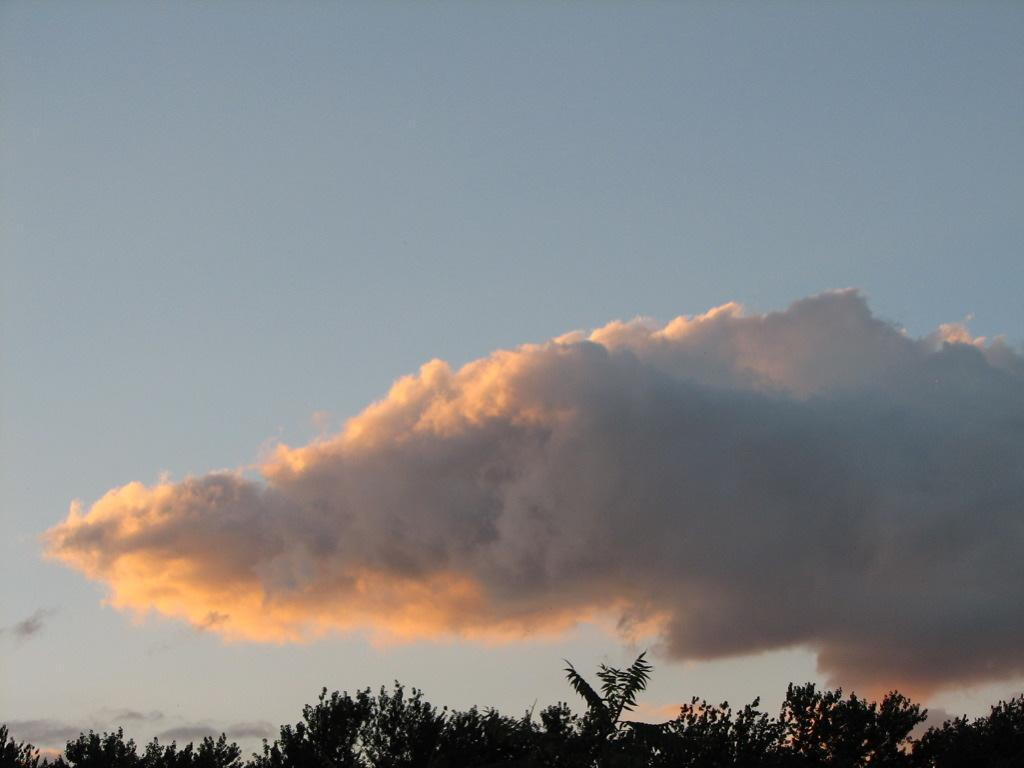What type of vegetation is at the bottom of the image? There are trees at the bottom of the image. What can be seen in the sky in the image? There is a cloud in the sky in the image. How many mittens are hanging on the trees in the image? There are no mittens present in the image; it features trees and a cloud in the sky. What type of payment is being made in the image? There is no payment being made in the image; it only shows trees and a cloud in the sky. 